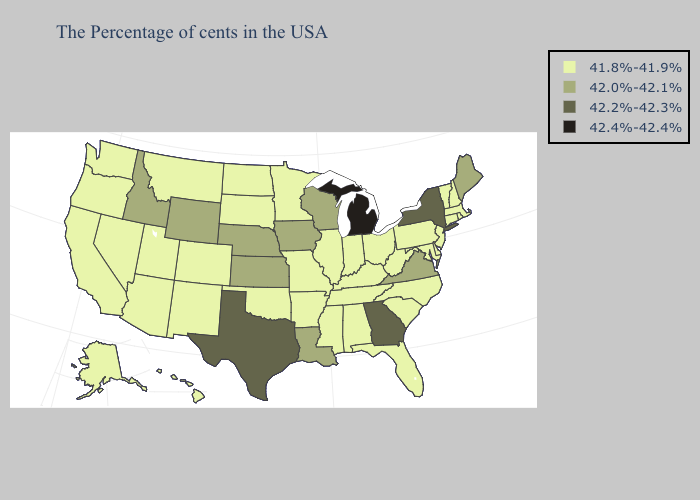Does Michigan have a lower value than North Carolina?
Write a very short answer. No. Does Colorado have the highest value in the USA?
Write a very short answer. No. What is the value of Montana?
Answer briefly. 41.8%-41.9%. Name the states that have a value in the range 42.0%-42.1%?
Short answer required. Maine, Virginia, Wisconsin, Louisiana, Iowa, Kansas, Nebraska, Wyoming, Idaho. What is the value of Wyoming?
Answer briefly. 42.0%-42.1%. What is the value of Nebraska?
Give a very brief answer. 42.0%-42.1%. Among the states that border Missouri , does Illinois have the highest value?
Be succinct. No. Does Alabama have the lowest value in the South?
Be succinct. Yes. Does the map have missing data?
Keep it brief. No. How many symbols are there in the legend?
Short answer required. 4. Name the states that have a value in the range 42.0%-42.1%?
Concise answer only. Maine, Virginia, Wisconsin, Louisiana, Iowa, Kansas, Nebraska, Wyoming, Idaho. Name the states that have a value in the range 42.4%-42.4%?
Quick response, please. Michigan. Among the states that border Vermont , does New Hampshire have the highest value?
Keep it brief. No. Which states hav the highest value in the Northeast?
Keep it brief. New York. What is the lowest value in the USA?
Keep it brief. 41.8%-41.9%. 